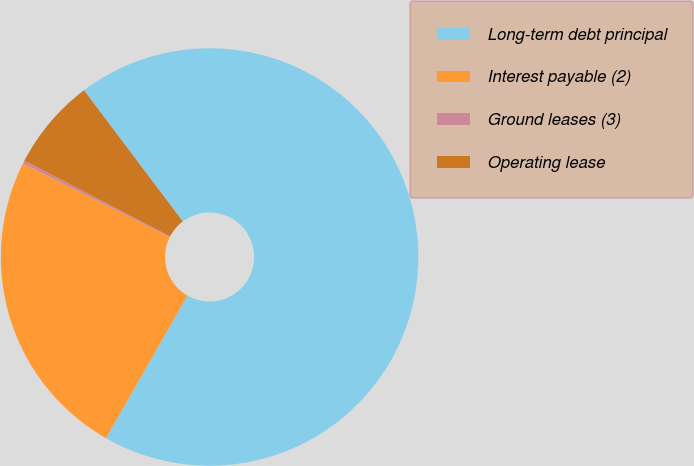<chart> <loc_0><loc_0><loc_500><loc_500><pie_chart><fcel>Long-term debt principal<fcel>Interest payable (2)<fcel>Ground leases (3)<fcel>Operating lease<nl><fcel>68.54%<fcel>24.12%<fcel>0.25%<fcel>7.08%<nl></chart> 